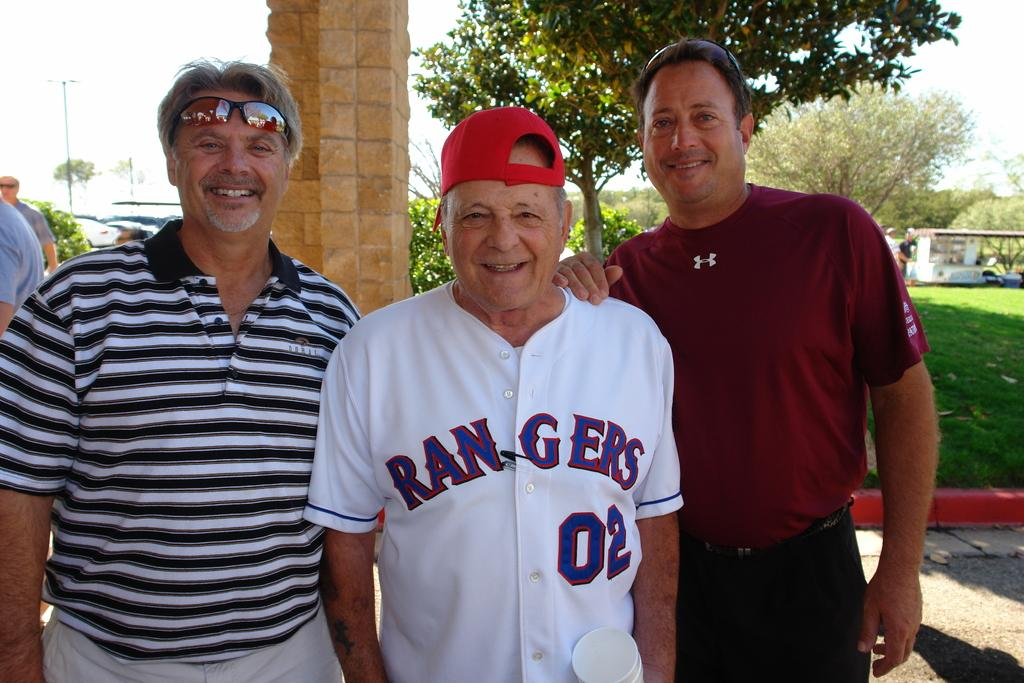<image>
Present a compact description of the photo's key features. Two men pose for a picture with an older man who is wearing a Rangers jersey for player number two and a red baseball cap. 